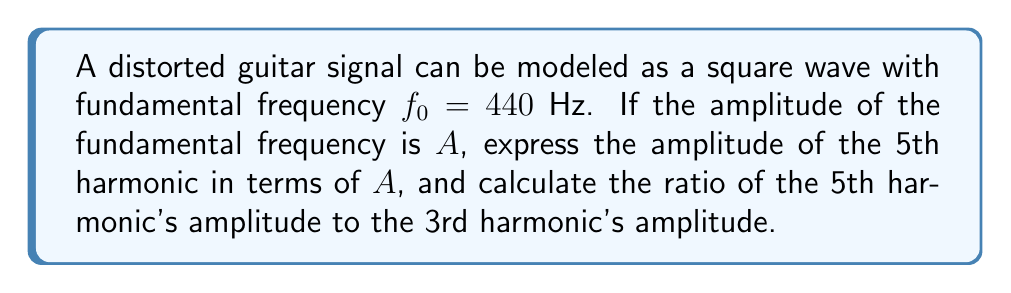Show me your answer to this math problem. 1) For a square wave, the Fourier series consists of only odd harmonics. The amplitude of the nth harmonic is given by:

   $$A_n = \frac{4A}{n\pi}$$

   where $n$ is an odd integer, and $A$ is the amplitude of the fundamental frequency.

2) For the 5th harmonic (n = 5):

   $$A_5 = \frac{4A}{5\pi}$$

3) For the 3rd harmonic (n = 3):

   $$A_3 = \frac{4A}{3\pi}$$

4) To find the ratio of the 5th harmonic's amplitude to the 3rd harmonic's amplitude:

   $$\frac{A_5}{A_3} = \frac{\frac{4A}{5\pi}}{\frac{4A}{3\pi}} = \frac{3}{5}$$

5) This ratio can be simplified to 3/5 or 0.6.
Answer: $A_5 = \frac{4A}{5\pi}$; Ratio $A_5/A_3 = 3/5$ 